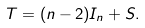Convert formula to latex. <formula><loc_0><loc_0><loc_500><loc_500>T = ( n - 2 ) I _ { n } + S .</formula> 